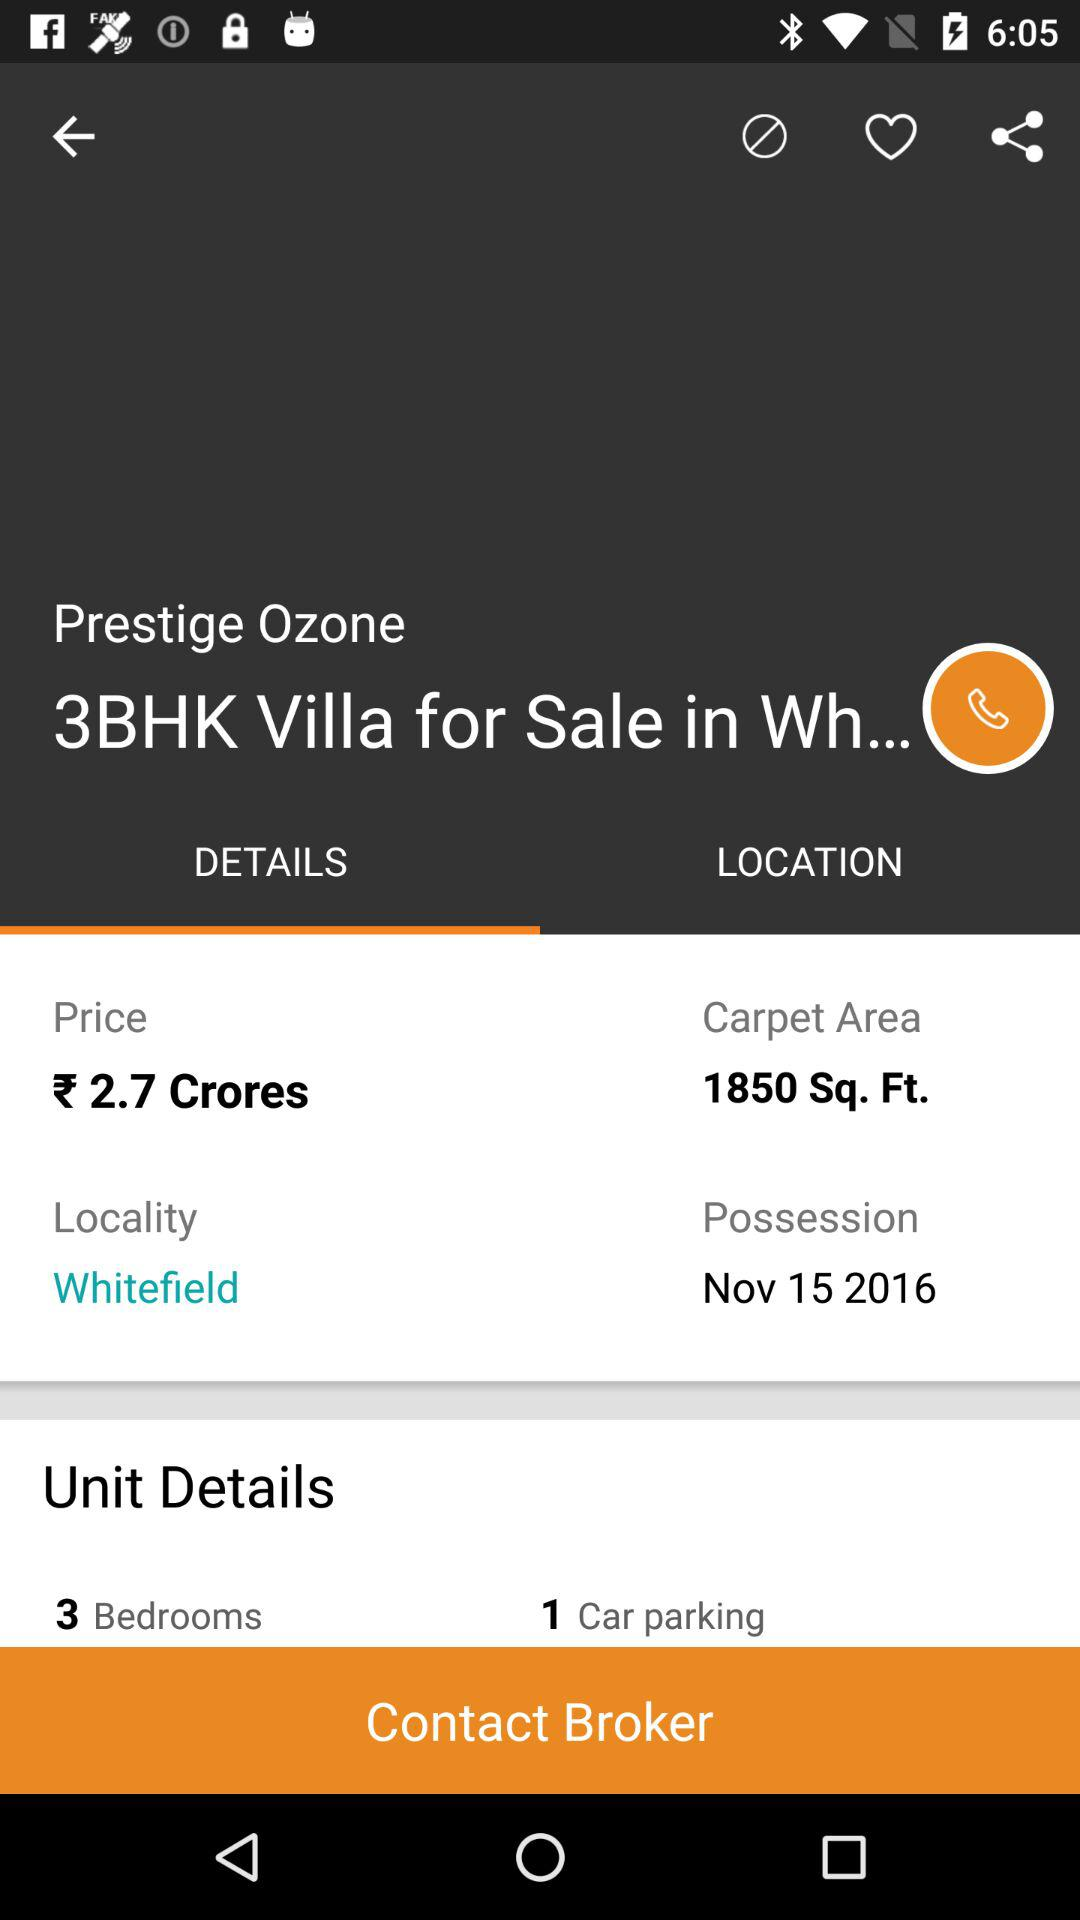How many bedrooms are there in this property?
Answer the question using a single word or phrase. 3 